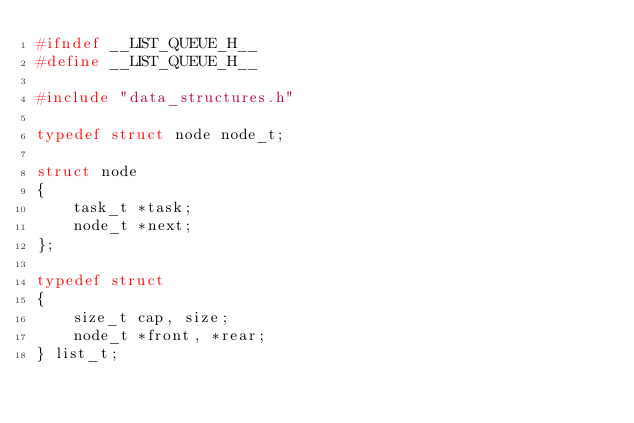Convert code to text. <code><loc_0><loc_0><loc_500><loc_500><_C_>#ifndef __LIST_QUEUE_H__
#define __LIST_QUEUE_H__

#include "data_structures.h"

typedef struct node node_t;

struct node
{
    task_t *task;
    node_t *next;
};

typedef struct
{
    size_t cap, size;
    node_t *front, *rear;
} list_t;
</code> 